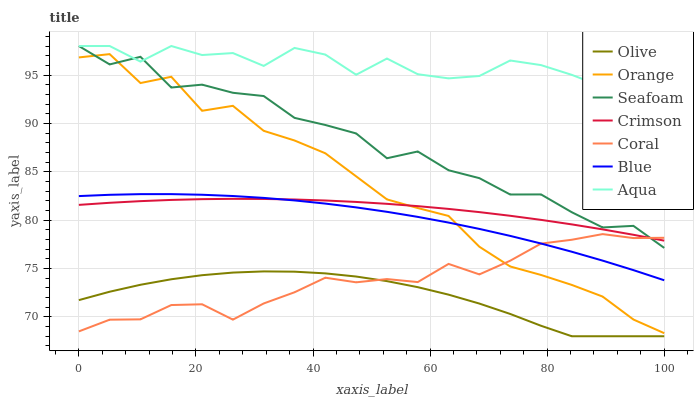Does Coral have the minimum area under the curve?
Answer yes or no. No. Does Coral have the maximum area under the curve?
Answer yes or no. No. Is Coral the smoothest?
Answer yes or no. No. Is Coral the roughest?
Answer yes or no. No. Does Coral have the lowest value?
Answer yes or no. No. Does Coral have the highest value?
Answer yes or no. No. Is Olive less than Orange?
Answer yes or no. Yes. Is Aqua greater than Crimson?
Answer yes or no. Yes. Does Olive intersect Orange?
Answer yes or no. No. 